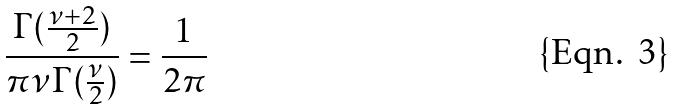<formula> <loc_0><loc_0><loc_500><loc_500>\frac { \Gamma ( \frac { \nu + 2 } { 2 } ) } { \pi \nu \Gamma ( \frac { \nu } { 2 } ) } = \frac { 1 } { 2 \pi }</formula> 